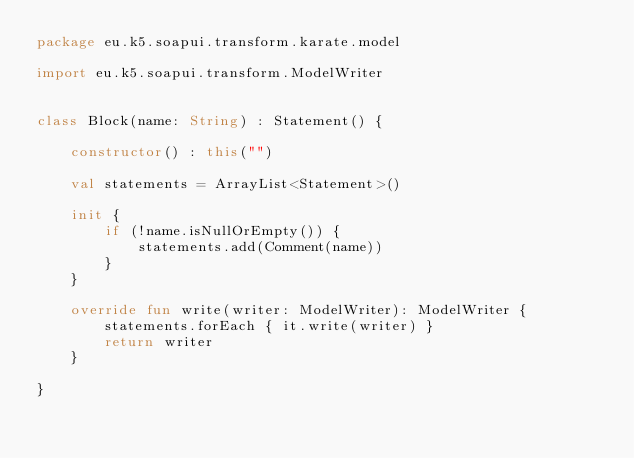Convert code to text. <code><loc_0><loc_0><loc_500><loc_500><_Kotlin_>package eu.k5.soapui.transform.karate.model

import eu.k5.soapui.transform.ModelWriter


class Block(name: String) : Statement() {

    constructor() : this("")

    val statements = ArrayList<Statement>()

    init {
        if (!name.isNullOrEmpty()) {
            statements.add(Comment(name))
        }
    }

    override fun write(writer: ModelWriter): ModelWriter {
        statements.forEach { it.write(writer) }
        return writer
    }

}</code> 